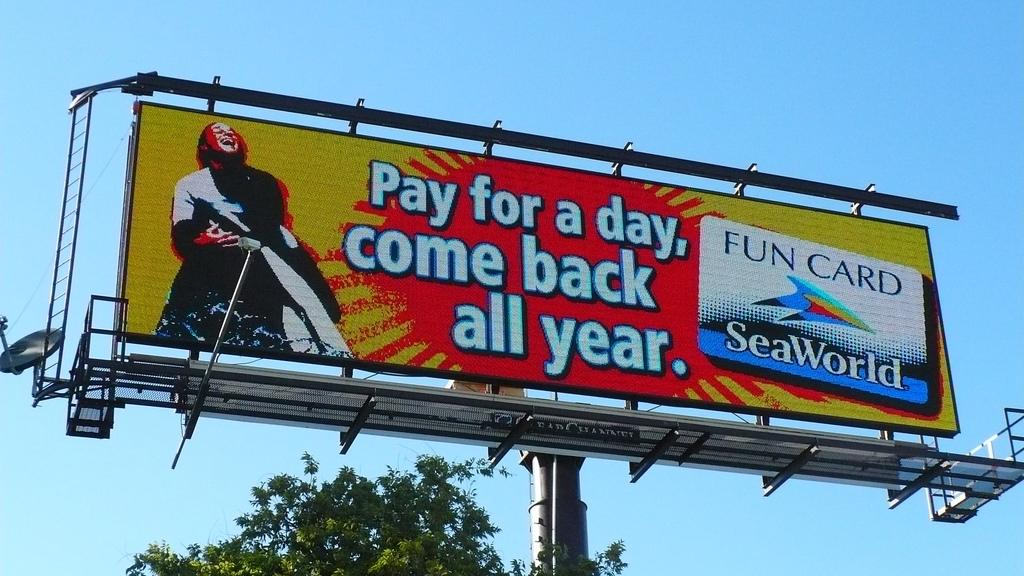Provide a one-sentence caption for the provided image. SeaWorld is advertised on a billboard that includes an offer to pay for a day and get the year covered. 